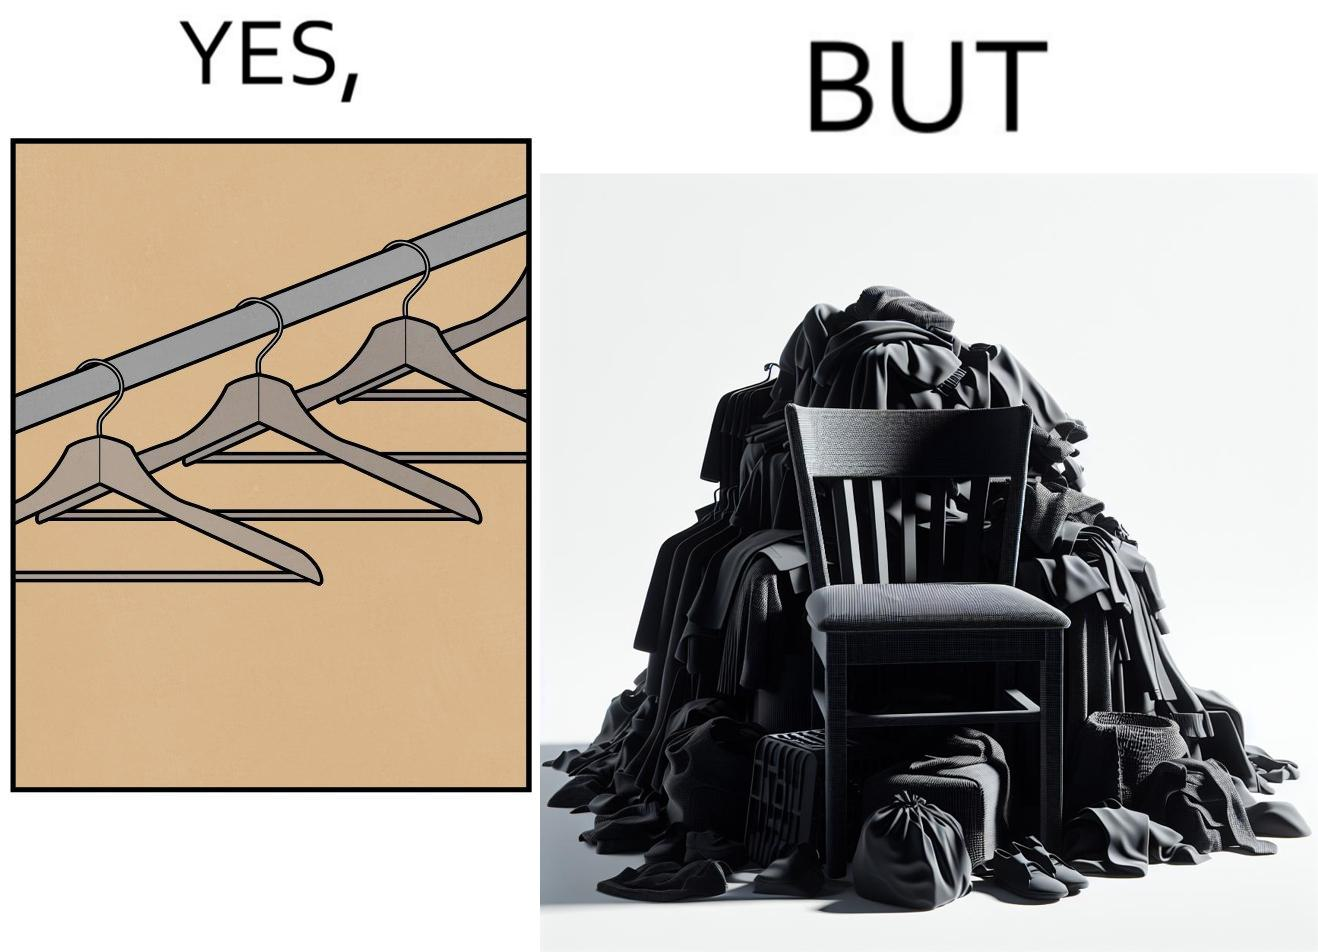What is shown in the left half versus the right half of this image? In the left part of the image: a set of hangars In the right part of the image: a chair with a pile of clothes 